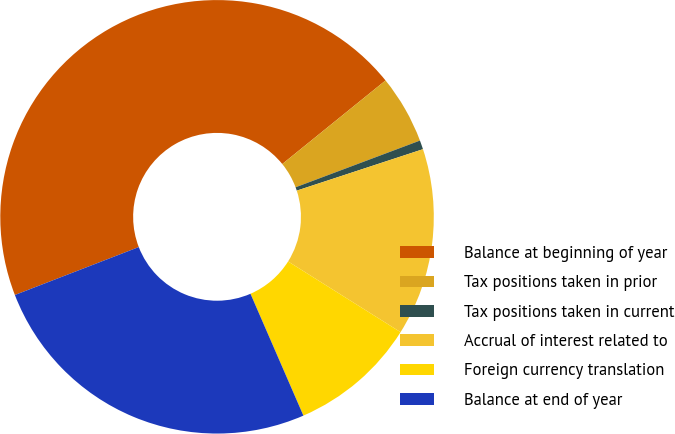<chart> <loc_0><loc_0><loc_500><loc_500><pie_chart><fcel>Balance at beginning of year<fcel>Tax positions taken in prior<fcel>Tax positions taken in current<fcel>Accrual of interest related to<fcel>Foreign currency translation<fcel>Balance at end of year<nl><fcel>45.05%<fcel>5.11%<fcel>0.67%<fcel>13.98%<fcel>9.55%<fcel>25.65%<nl></chart> 